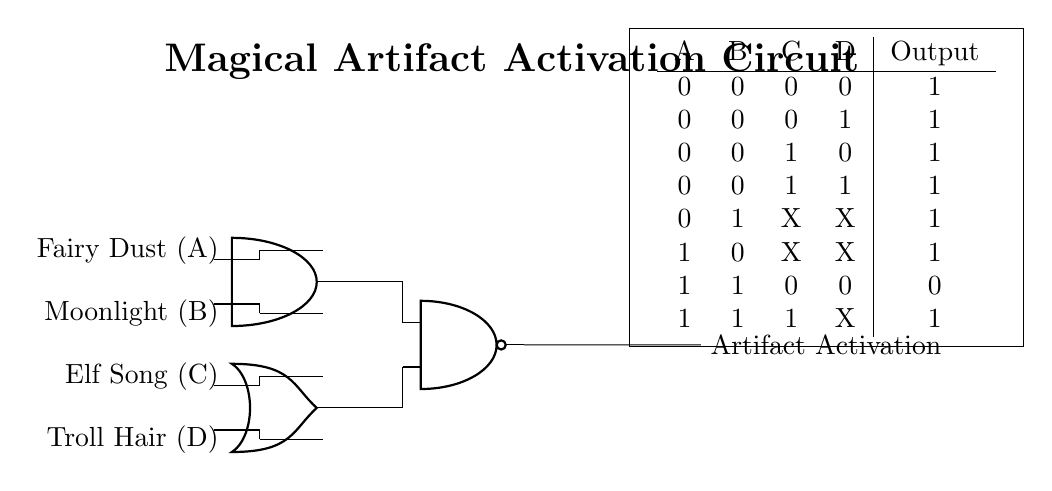What are the inputs to the circuit? The inputs to the circuit are Fairy Dust, Moonlight, Elf Song, and Troll Hair, which are labeled on the left side of the diagram.
Answer: Fairy Dust, Moonlight, Elf Song, Troll Hair What type of logic gate is used first in the circuit? The first layer of gates includes an AND gate, which combines inputs to determine if both inputs are true.
Answer: AND gate What is the output when all inputs are zero? Referring to the truth table, when all inputs A, B, C, and D are zero, the output is one.
Answer: One How does the presence of Elf Song or Troll Hair affect the output? When Elf Song and Troll Hair inputs are one, the output remains one regardless of the other inputs due to the OR gate structure.
Answer: Output remains one In a scenario where Fairy Dust and Moonlight are both one, what will be the output? If both Fairy Dust and Moonlight are one, the AND gate will output one, which then leads into the NAND gate. However, the specific combination doesn't affect the output unless other inputs are accounted as one or zero. Therefore, it causes a zero output.
Answer: Zero What is the significance of the "X" in the truth table? The "X" represents a don't care condition, meaning the output can be either zero or one and the specific state of those inputs does not affect the outcome in those cases.
Answer: Don't care condition What is the final output of the circuit called? The final output is labeled as Artifact Activation, indicating whether the magical artifact is activated based on the input conditions.
Answer: Artifact Activation 